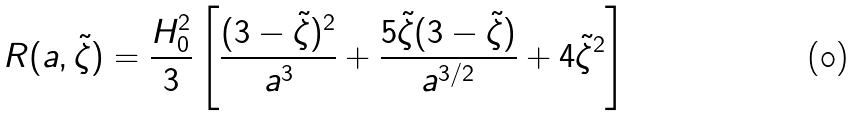Convert formula to latex. <formula><loc_0><loc_0><loc_500><loc_500>R ( a , \tilde { \zeta } ) = \frac { H _ { 0 } ^ { 2 } } { 3 } \left [ \frac { ( 3 - \tilde { \zeta } ) ^ { 2 } } { a ^ { 3 } } + \frac { 5 \tilde { \zeta } ( 3 - \tilde { \zeta } ) } { a ^ { 3 / 2 } } + 4 \tilde { \zeta } ^ { 2 } \right ]</formula> 